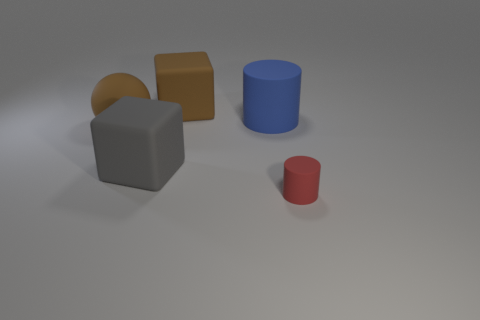Add 2 large brown blocks. How many objects exist? 7 Subtract all blue cylinders. How many cylinders are left? 1 Subtract all cylinders. How many objects are left? 3 Subtract 2 cubes. How many cubes are left? 0 Subtract all big rubber cubes. Subtract all gray matte things. How many objects are left? 2 Add 5 tiny objects. How many tiny objects are left? 6 Add 4 gray cubes. How many gray cubes exist? 5 Subtract 0 blue balls. How many objects are left? 5 Subtract all cyan cylinders. Subtract all cyan cubes. How many cylinders are left? 2 Subtract all green cubes. How many gray spheres are left? 0 